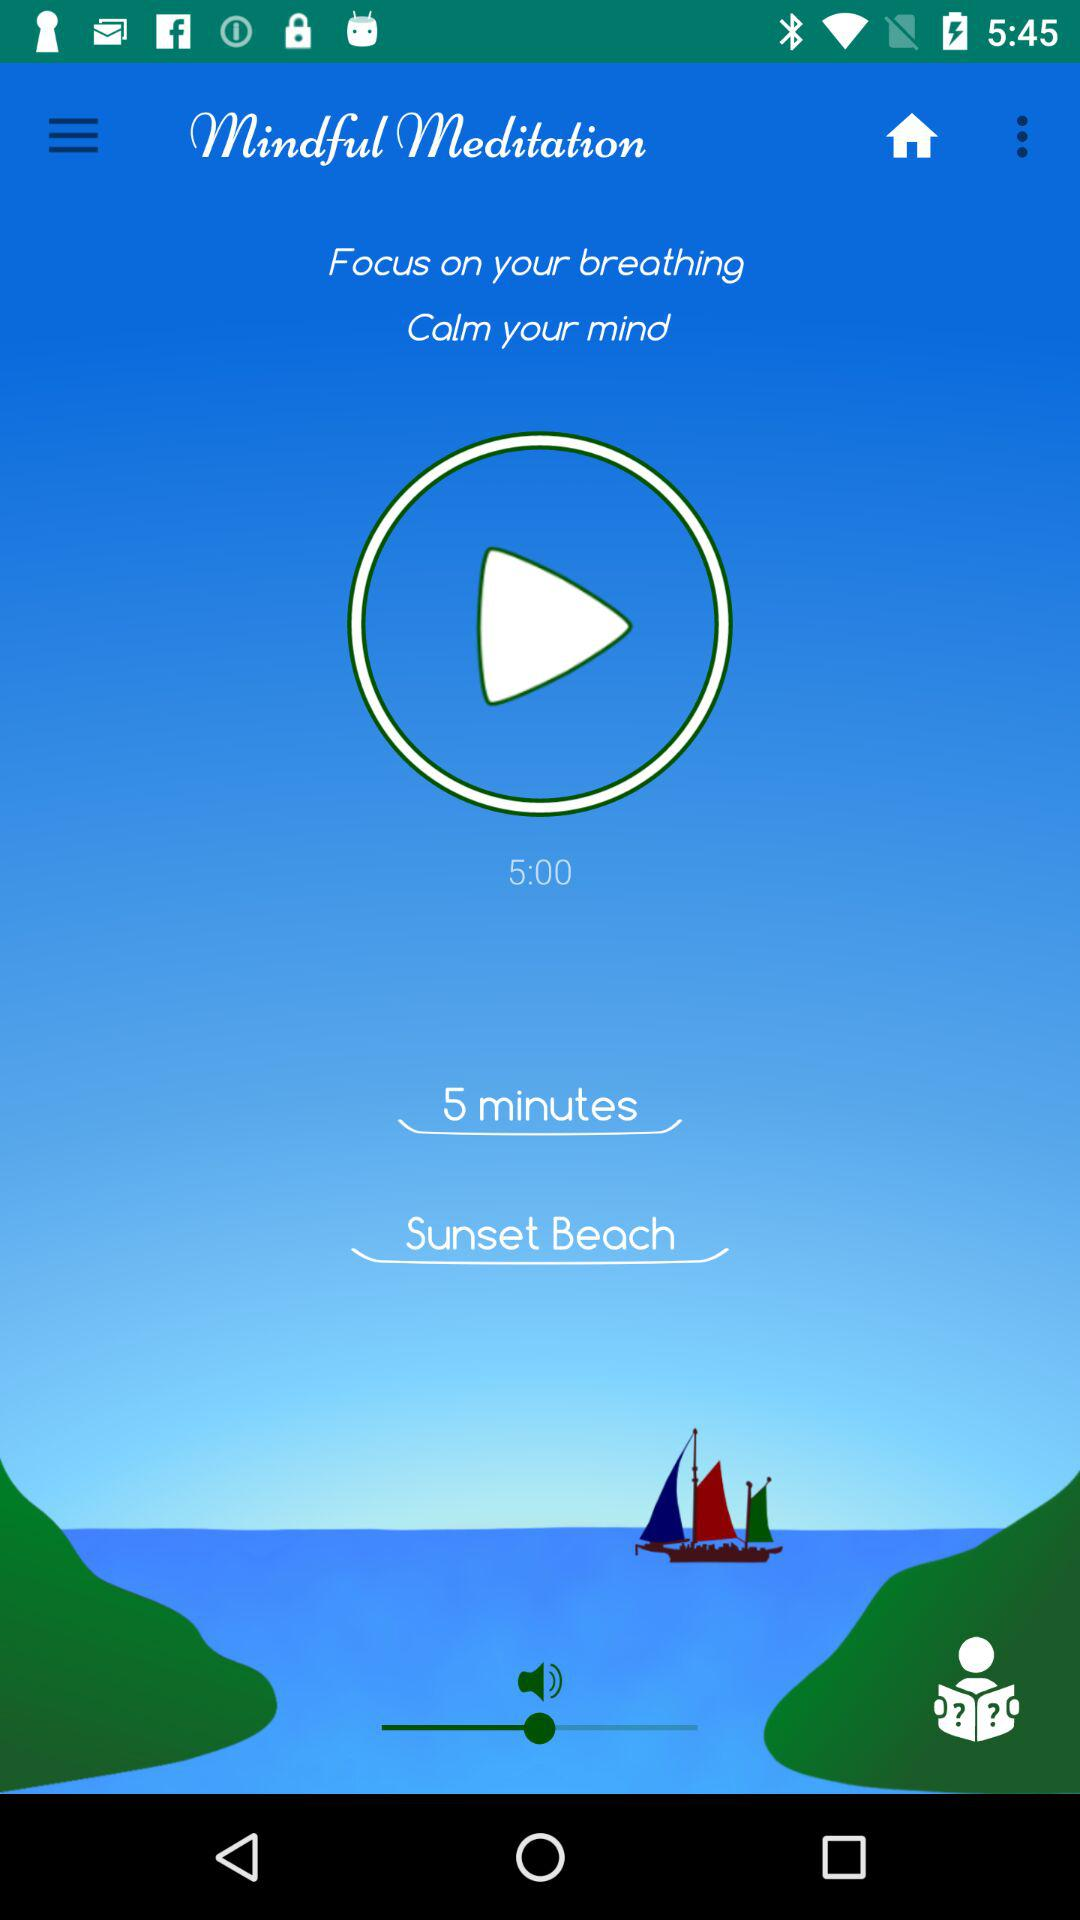What is the title of the audio? The title of the audio is "Sunset Beach". 